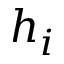Convert formula to latex. <formula><loc_0><loc_0><loc_500><loc_500>h _ { i }</formula> 